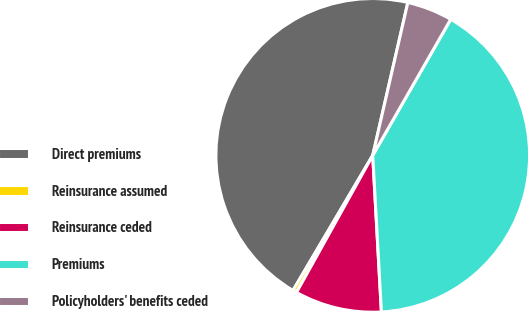Convert chart to OTSL. <chart><loc_0><loc_0><loc_500><loc_500><pie_chart><fcel>Direct premiums<fcel>Reinsurance assumed<fcel>Reinsurance ceded<fcel>Premiums<fcel>Policyholders' benefits ceded<nl><fcel>45.11%<fcel>0.41%<fcel>8.96%<fcel>40.84%<fcel>4.69%<nl></chart> 